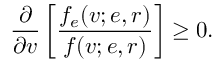Convert formula to latex. <formula><loc_0><loc_0><loc_500><loc_500>\frac { \partial } { \partial v } \left [ \frac { f _ { e } ( v ; e , r ) } { f ( v ; e , r ) } \right ] \geq 0 .</formula> 